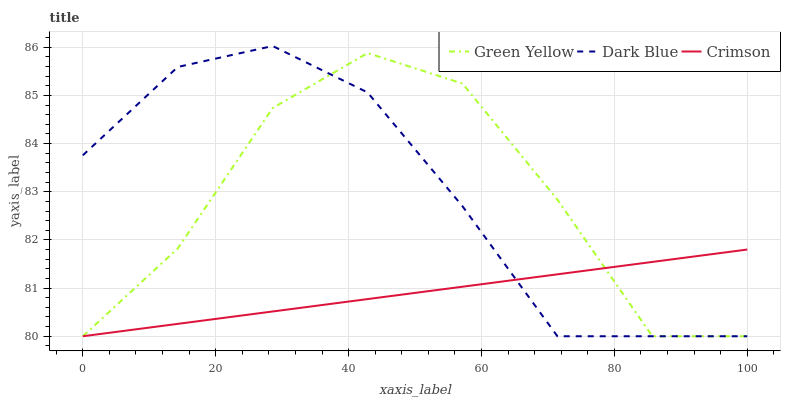Does Crimson have the minimum area under the curve?
Answer yes or no. Yes. Does Dark Blue have the maximum area under the curve?
Answer yes or no. Yes. Does Green Yellow have the minimum area under the curve?
Answer yes or no. No. Does Green Yellow have the maximum area under the curve?
Answer yes or no. No. Is Crimson the smoothest?
Answer yes or no. Yes. Is Green Yellow the roughest?
Answer yes or no. Yes. Is Dark Blue the smoothest?
Answer yes or no. No. Is Dark Blue the roughest?
Answer yes or no. No. Does Crimson have the lowest value?
Answer yes or no. Yes. Does Dark Blue have the highest value?
Answer yes or no. Yes. Does Green Yellow have the highest value?
Answer yes or no. No. Does Dark Blue intersect Green Yellow?
Answer yes or no. Yes. Is Dark Blue less than Green Yellow?
Answer yes or no. No. Is Dark Blue greater than Green Yellow?
Answer yes or no. No. 